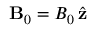<formula> <loc_0><loc_0><loc_500><loc_500>{ B } _ { 0 } = B _ { 0 } \, \hat { z }</formula> 